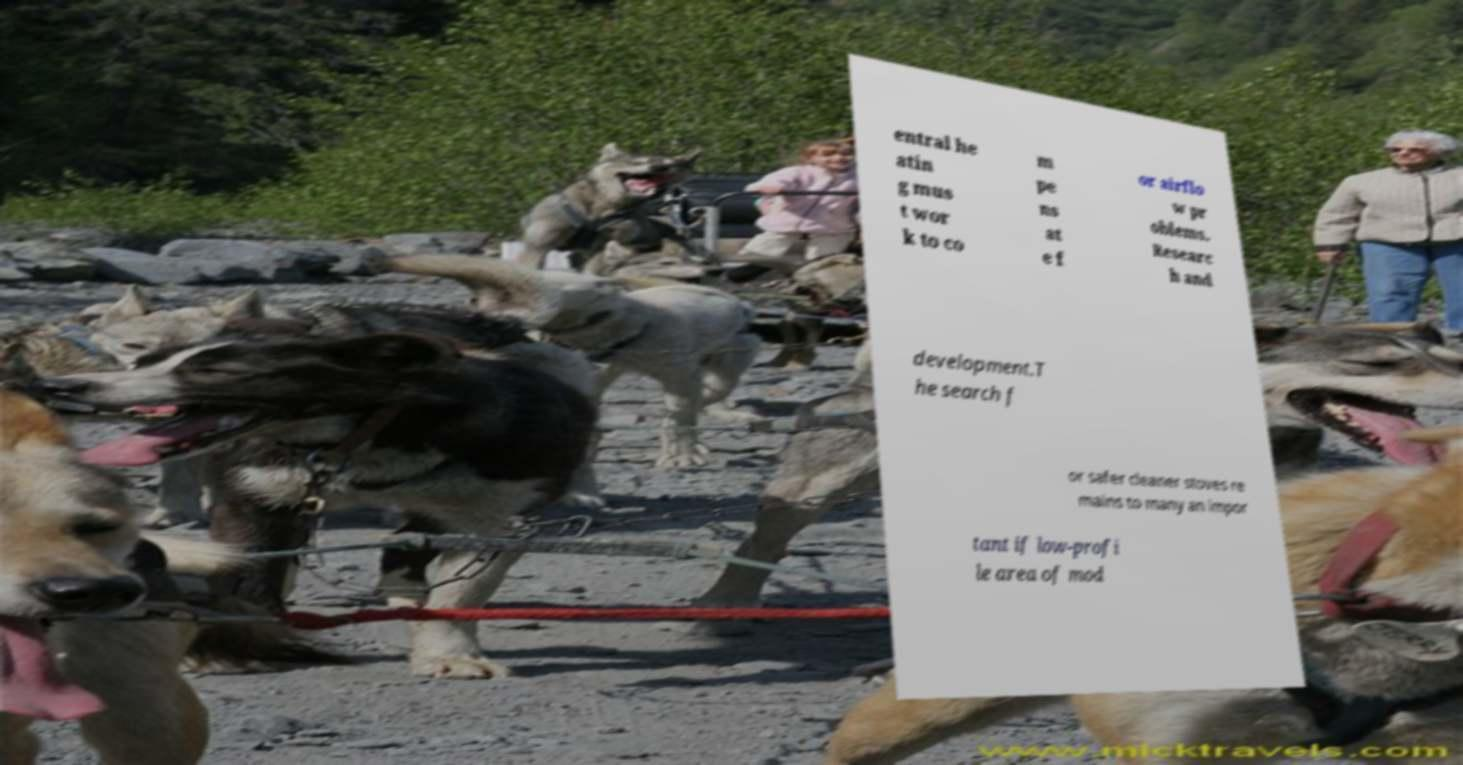Please read and relay the text visible in this image. What does it say? entral he atin g mus t wor k to co m pe ns at e f or airflo w pr oblems. Researc h and development.T he search f or safer cleaner stoves re mains to many an impor tant if low-profi le area of mod 